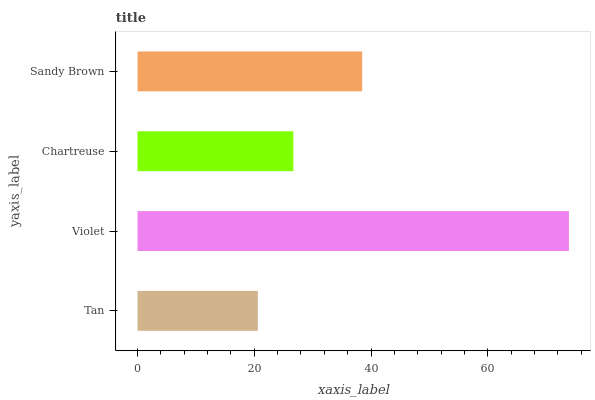Is Tan the minimum?
Answer yes or no. Yes. Is Violet the maximum?
Answer yes or no. Yes. Is Chartreuse the minimum?
Answer yes or no. No. Is Chartreuse the maximum?
Answer yes or no. No. Is Violet greater than Chartreuse?
Answer yes or no. Yes. Is Chartreuse less than Violet?
Answer yes or no. Yes. Is Chartreuse greater than Violet?
Answer yes or no. No. Is Violet less than Chartreuse?
Answer yes or no. No. Is Sandy Brown the high median?
Answer yes or no. Yes. Is Chartreuse the low median?
Answer yes or no. Yes. Is Tan the high median?
Answer yes or no. No. Is Tan the low median?
Answer yes or no. No. 